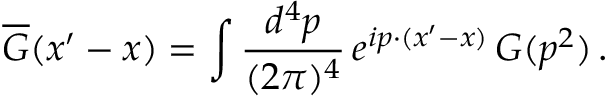<formula> <loc_0><loc_0><loc_500><loc_500>\overline { G } ( x ^ { \prime } - x ) = \int \frac { d ^ { 4 } p } { ( 2 \pi ) ^ { 4 } } \, e ^ { i p \cdot ( x ^ { \prime } - x ) } \, G ( p ^ { 2 } ) \, .</formula> 